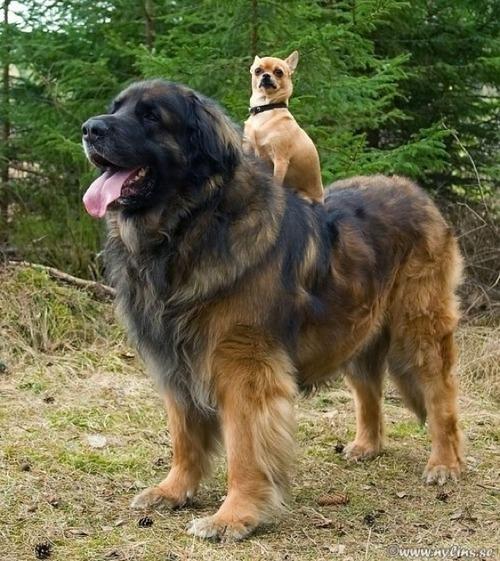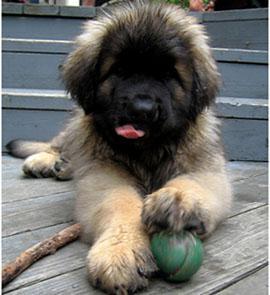The first image is the image on the left, the second image is the image on the right. Considering the images on both sides, is "The left photo depicts a puppy with its front paws propped up on something." valid? Answer yes or no. No. 